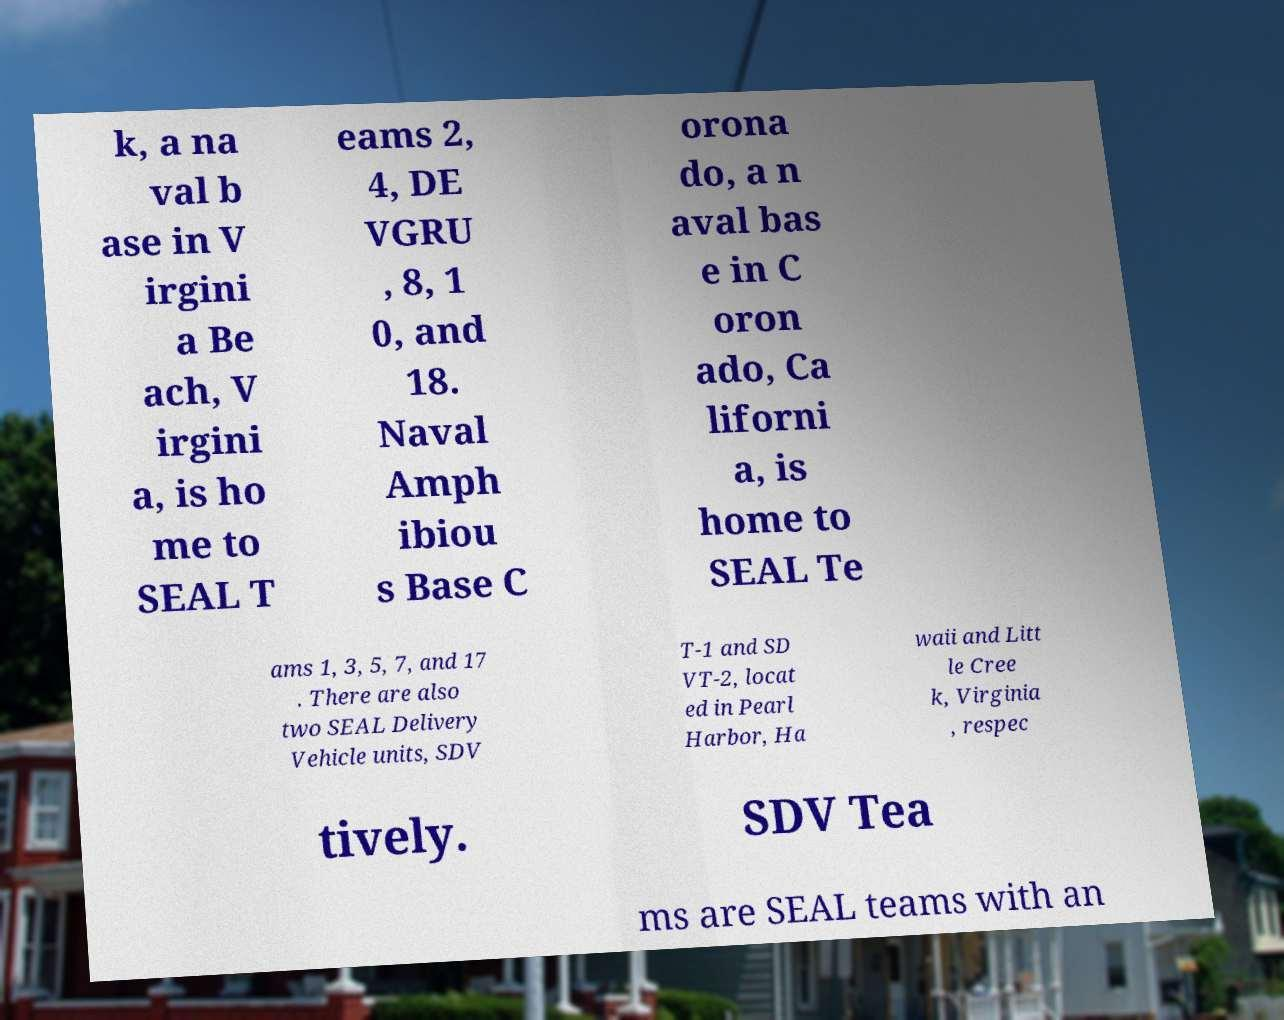There's text embedded in this image that I need extracted. Can you transcribe it verbatim? k, a na val b ase in V irgini a Be ach, V irgini a, is ho me to SEAL T eams 2, 4, DE VGRU , 8, 1 0, and 18. Naval Amph ibiou s Base C orona do, a n aval bas e in C oron ado, Ca liforni a, is home to SEAL Te ams 1, 3, 5, 7, and 17 . There are also two SEAL Delivery Vehicle units, SDV T-1 and SD VT-2, locat ed in Pearl Harbor, Ha waii and Litt le Cree k, Virginia , respec tively. SDV Tea ms are SEAL teams with an 